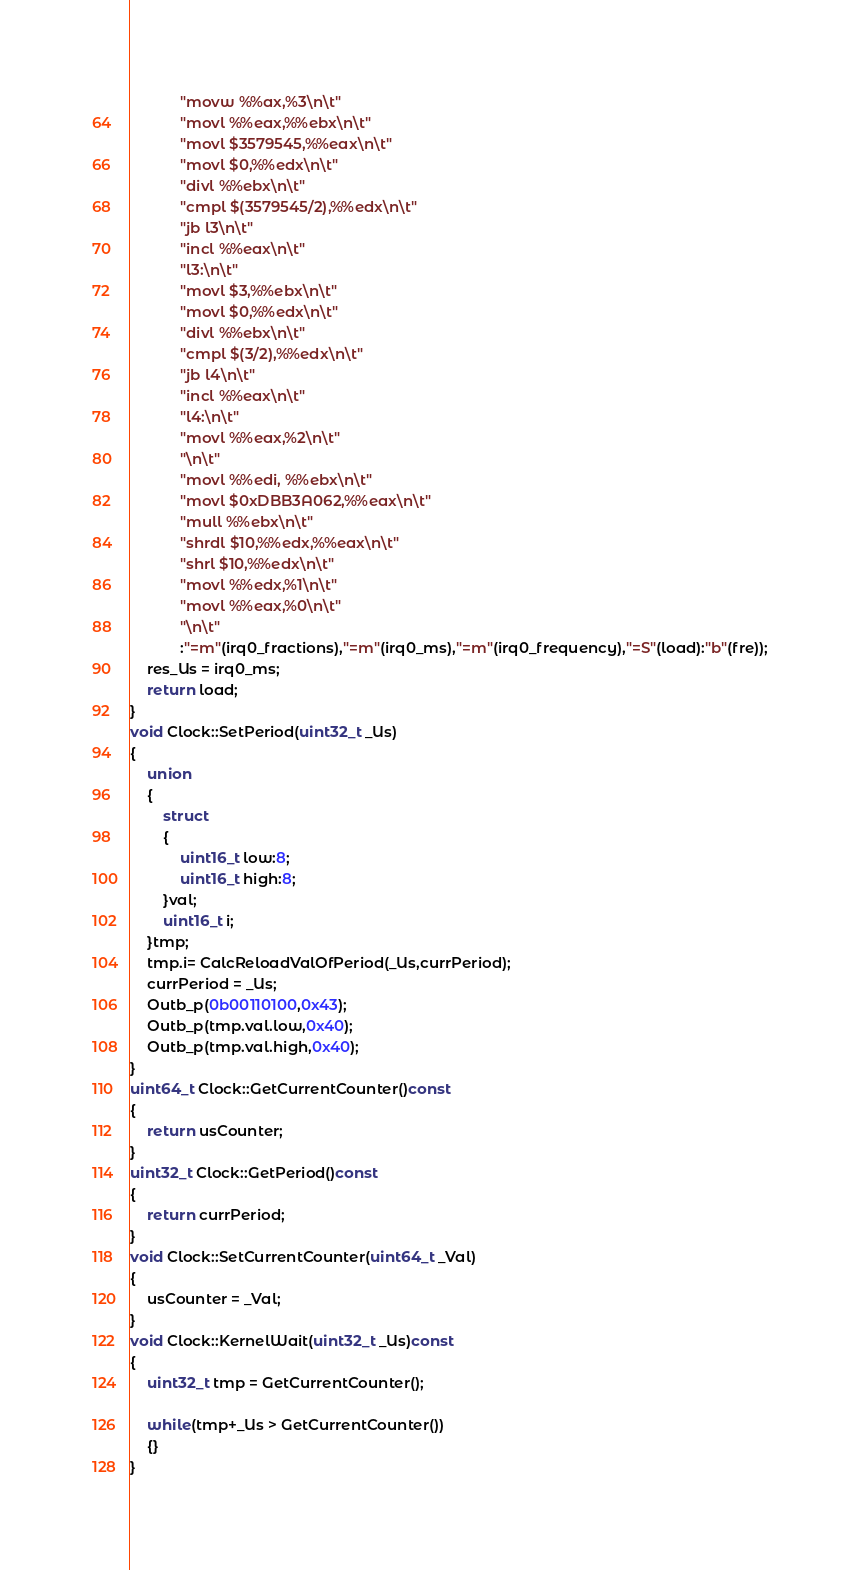<code> <loc_0><loc_0><loc_500><loc_500><_C++_>			"movw %%ax,%3\n\t"
			"movl %%eax,%%ebx\n\t"
			"movl $3579545,%%eax\n\t"
			"movl $0,%%edx\n\t"
			"divl %%ebx\n\t"
			"cmpl $(3579545/2),%%edx\n\t"
			"jb l3\n\t"
			"incl %%eax\n\t"
			"l3:\n\t"
			"movl $3,%%ebx\n\t"
			"movl $0,%%edx\n\t"
			"divl %%ebx\n\t"
			"cmpl $(3/2),%%edx\n\t"
			"jb l4\n\t"
			"incl %%eax\n\t"
			"l4:\n\t"
			"movl %%eax,%2\n\t"
			"\n\t"
			"movl %%edi, %%ebx\n\t"
			"movl $0xDBB3A062,%%eax\n\t"
			"mull %%ebx\n\t"
			"shrdl $10,%%edx,%%eax\n\t"
			"shrl $10,%%edx\n\t"
			"movl %%edx,%1\n\t"
			"movl %%eax,%0\n\t"
			"\n\t"
			:"=m"(irq0_fractions),"=m"(irq0_ms),"=m"(irq0_frequency),"=S"(load):"b"(fre));
	res_Us = irq0_ms;
	return load;
}
void Clock::SetPeriod(uint32_t _Us)
{
	union
	{
		struct
		{
			uint16_t low:8;
			uint16_t high:8;
		}val;
		uint16_t i;
	}tmp;
	tmp.i= CalcReloadValOfPeriod(_Us,currPeriod);
	currPeriod = _Us;
	Outb_p(0b00110100,0x43);	
	Outb_p(tmp.val.low,0x40);
	Outb_p(tmp.val.high,0x40);
}
uint64_t Clock::GetCurrentCounter()const
{
	return usCounter;
}
uint32_t Clock::GetPeriod()const
{
	return currPeriod;	
}
void Clock::SetCurrentCounter(uint64_t _Val)
{
	usCounter = _Val;
}
void Clock::KernelWait(uint32_t _Us)const
{
	uint32_t tmp = GetCurrentCounter();

	while(tmp+_Us > GetCurrentCounter())
	{}
}
</code> 